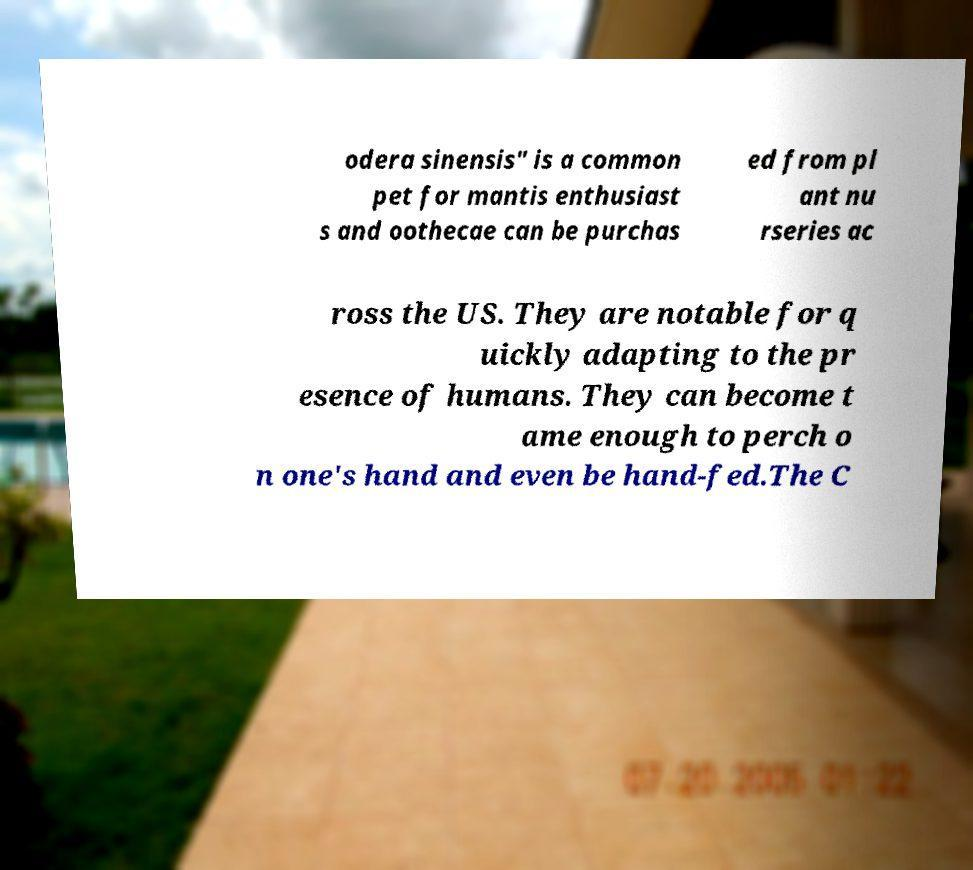What messages or text are displayed in this image? I need them in a readable, typed format. odera sinensis" is a common pet for mantis enthusiast s and oothecae can be purchas ed from pl ant nu rseries ac ross the US. They are notable for q uickly adapting to the pr esence of humans. They can become t ame enough to perch o n one's hand and even be hand-fed.The C 